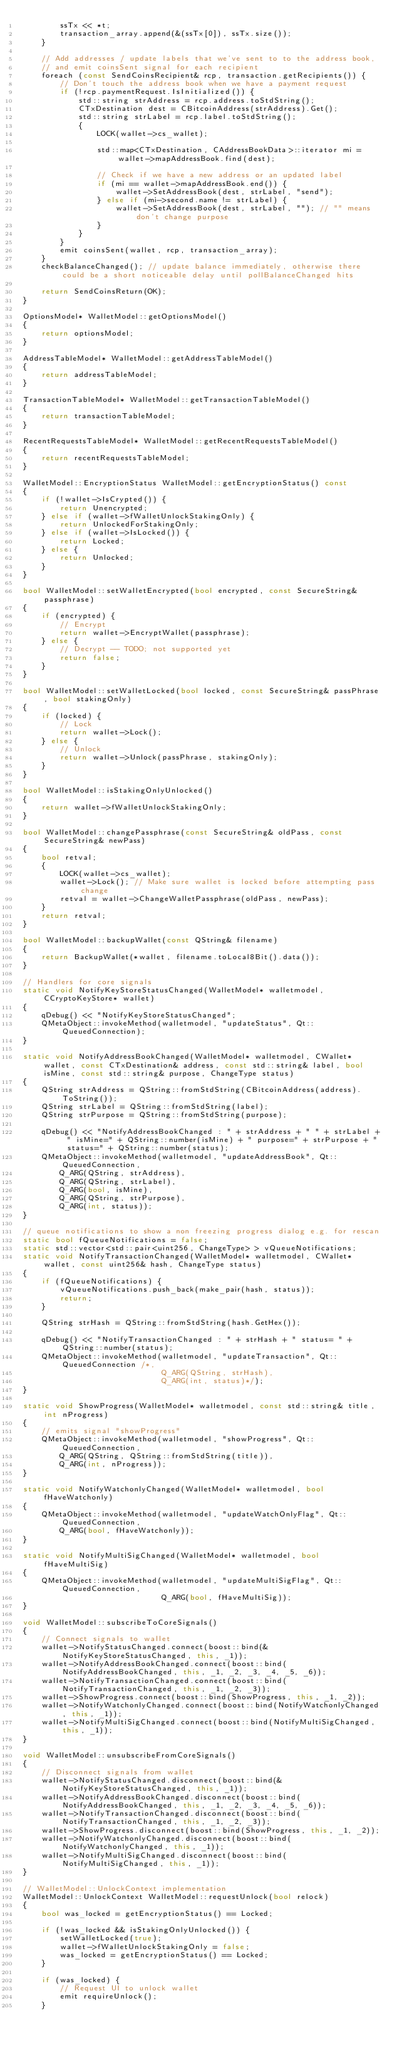Convert code to text. <code><loc_0><loc_0><loc_500><loc_500><_C++_>        ssTx << *t;
        transaction_array.append(&(ssTx[0]), ssTx.size());
    }

    // Add addresses / update labels that we've sent to to the address book,
    // and emit coinsSent signal for each recipient
    foreach (const SendCoinsRecipient& rcp, transaction.getRecipients()) {
        // Don't touch the address book when we have a payment request
        if (!rcp.paymentRequest.IsInitialized()) {
            std::string strAddress = rcp.address.toStdString();
            CTxDestination dest = CBitcoinAddress(strAddress).Get();
            std::string strLabel = rcp.label.toStdString();
            {
                LOCK(wallet->cs_wallet);

                std::map<CTxDestination, CAddressBookData>::iterator mi = wallet->mapAddressBook.find(dest);

                // Check if we have a new address or an updated label
                if (mi == wallet->mapAddressBook.end()) {
                    wallet->SetAddressBook(dest, strLabel, "send");
                } else if (mi->second.name != strLabel) {
                    wallet->SetAddressBook(dest, strLabel, ""); // "" means don't change purpose
                }
            }
        }
        emit coinsSent(wallet, rcp, transaction_array);
    }
    checkBalanceChanged(); // update balance immediately, otherwise there could be a short noticeable delay until pollBalanceChanged hits

    return SendCoinsReturn(OK);
}

OptionsModel* WalletModel::getOptionsModel()
{
    return optionsModel;
}

AddressTableModel* WalletModel::getAddressTableModel()
{
    return addressTableModel;
}

TransactionTableModel* WalletModel::getTransactionTableModel()
{
    return transactionTableModel;
}

RecentRequestsTableModel* WalletModel::getRecentRequestsTableModel()
{
    return recentRequestsTableModel;
}

WalletModel::EncryptionStatus WalletModel::getEncryptionStatus() const
{
    if (!wallet->IsCrypted()) {
        return Unencrypted;
    } else if (wallet->fWalletUnlockStakingOnly) {
        return UnlockedForStakingOnly;
    } else if (wallet->IsLocked()) {
        return Locked;
    } else {
        return Unlocked;
    }
}

bool WalletModel::setWalletEncrypted(bool encrypted, const SecureString& passphrase)
{
    if (encrypted) {
        // Encrypt
        return wallet->EncryptWallet(passphrase);
    } else {
        // Decrypt -- TODO; not supported yet
        return false;
    }
}

bool WalletModel::setWalletLocked(bool locked, const SecureString& passPhrase, bool stakingOnly)
{
    if (locked) {
        // Lock
        return wallet->Lock();
    } else {
        // Unlock
        return wallet->Unlock(passPhrase, stakingOnly);
    }
}

bool WalletModel::isStakingOnlyUnlocked()
{
    return wallet->fWalletUnlockStakingOnly;
}

bool WalletModel::changePassphrase(const SecureString& oldPass, const SecureString& newPass)
{
    bool retval;
    {
        LOCK(wallet->cs_wallet);
        wallet->Lock(); // Make sure wallet is locked before attempting pass change
        retval = wallet->ChangeWalletPassphrase(oldPass, newPass);
    }
    return retval;
}

bool WalletModel::backupWallet(const QString& filename)
{
    return BackupWallet(*wallet, filename.toLocal8Bit().data());
}

// Handlers for core signals
static void NotifyKeyStoreStatusChanged(WalletModel* walletmodel, CCryptoKeyStore* wallet)
{
    qDebug() << "NotifyKeyStoreStatusChanged";
    QMetaObject::invokeMethod(walletmodel, "updateStatus", Qt::QueuedConnection);
}

static void NotifyAddressBookChanged(WalletModel* walletmodel, CWallet* wallet, const CTxDestination& address, const std::string& label, bool isMine, const std::string& purpose, ChangeType status)
{
    QString strAddress = QString::fromStdString(CBitcoinAddress(address).ToString());
    QString strLabel = QString::fromStdString(label);
    QString strPurpose = QString::fromStdString(purpose);

    qDebug() << "NotifyAddressBookChanged : " + strAddress + " " + strLabel + " isMine=" + QString::number(isMine) + " purpose=" + strPurpose + " status=" + QString::number(status);
    QMetaObject::invokeMethod(walletmodel, "updateAddressBook", Qt::QueuedConnection,
        Q_ARG(QString, strAddress),
        Q_ARG(QString, strLabel),
        Q_ARG(bool, isMine),
        Q_ARG(QString, strPurpose),
        Q_ARG(int, status));
}

// queue notifications to show a non freezing progress dialog e.g. for rescan
static bool fQueueNotifications = false;
static std::vector<std::pair<uint256, ChangeType> > vQueueNotifications;
static void NotifyTransactionChanged(WalletModel* walletmodel, CWallet* wallet, const uint256& hash, ChangeType status)
{
    if (fQueueNotifications) {
        vQueueNotifications.push_back(make_pair(hash, status));
        return;
    }

    QString strHash = QString::fromStdString(hash.GetHex());

    qDebug() << "NotifyTransactionChanged : " + strHash + " status= " + QString::number(status);
    QMetaObject::invokeMethod(walletmodel, "updateTransaction", Qt::QueuedConnection /*,
                              Q_ARG(QString, strHash),
                              Q_ARG(int, status)*/);
}

static void ShowProgress(WalletModel* walletmodel, const std::string& title, int nProgress)
{
    // emits signal "showProgress"
    QMetaObject::invokeMethod(walletmodel, "showProgress", Qt::QueuedConnection,
        Q_ARG(QString, QString::fromStdString(title)),
        Q_ARG(int, nProgress));
}

static void NotifyWatchonlyChanged(WalletModel* walletmodel, bool fHaveWatchonly)
{
    QMetaObject::invokeMethod(walletmodel, "updateWatchOnlyFlag", Qt::QueuedConnection,
        Q_ARG(bool, fHaveWatchonly));
}

static void NotifyMultiSigChanged(WalletModel* walletmodel, bool fHaveMultiSig)
{
    QMetaObject::invokeMethod(walletmodel, "updateMultiSigFlag", Qt::QueuedConnection,
                              Q_ARG(bool, fHaveMultiSig));
}

void WalletModel::subscribeToCoreSignals()
{
    // Connect signals to wallet
    wallet->NotifyStatusChanged.connect(boost::bind(&NotifyKeyStoreStatusChanged, this, _1));
    wallet->NotifyAddressBookChanged.connect(boost::bind(NotifyAddressBookChanged, this, _1, _2, _3, _4, _5, _6));
    wallet->NotifyTransactionChanged.connect(boost::bind(NotifyTransactionChanged, this, _1, _2, _3));
    wallet->ShowProgress.connect(boost::bind(ShowProgress, this, _1, _2));
    wallet->NotifyWatchonlyChanged.connect(boost::bind(NotifyWatchonlyChanged, this, _1));
    wallet->NotifyMultiSigChanged.connect(boost::bind(NotifyMultiSigChanged, this, _1));
}

void WalletModel::unsubscribeFromCoreSignals()
{
    // Disconnect signals from wallet
    wallet->NotifyStatusChanged.disconnect(boost::bind(&NotifyKeyStoreStatusChanged, this, _1));
    wallet->NotifyAddressBookChanged.disconnect(boost::bind(NotifyAddressBookChanged, this, _1, _2, _3, _4, _5, _6));
    wallet->NotifyTransactionChanged.disconnect(boost::bind(NotifyTransactionChanged, this, _1, _2, _3));
    wallet->ShowProgress.disconnect(boost::bind(ShowProgress, this, _1, _2));
    wallet->NotifyWatchonlyChanged.disconnect(boost::bind(NotifyWatchonlyChanged, this, _1));
    wallet->NotifyMultiSigChanged.disconnect(boost::bind(NotifyMultiSigChanged, this, _1));
}

// WalletModel::UnlockContext implementation
WalletModel::UnlockContext WalletModel::requestUnlock(bool relock)
{
    bool was_locked = getEncryptionStatus() == Locked;

    if (!was_locked && isStakingOnlyUnlocked()) {
        setWalletLocked(true);
        wallet->fWalletUnlockStakingOnly = false;
        was_locked = getEncryptionStatus() == Locked;
    }

    if (was_locked) {
        // Request UI to unlock wallet
        emit requireUnlock();
    }</code> 